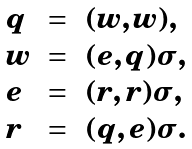Convert formula to latex. <formula><loc_0><loc_0><loc_500><loc_500>\begin{array} { l c l } q & = & ( w , w ) , \\ w & = & ( e , q ) \sigma , \\ e & = & ( r , r ) \sigma , \\ r & = & ( q , e ) \sigma . \end{array}</formula> 